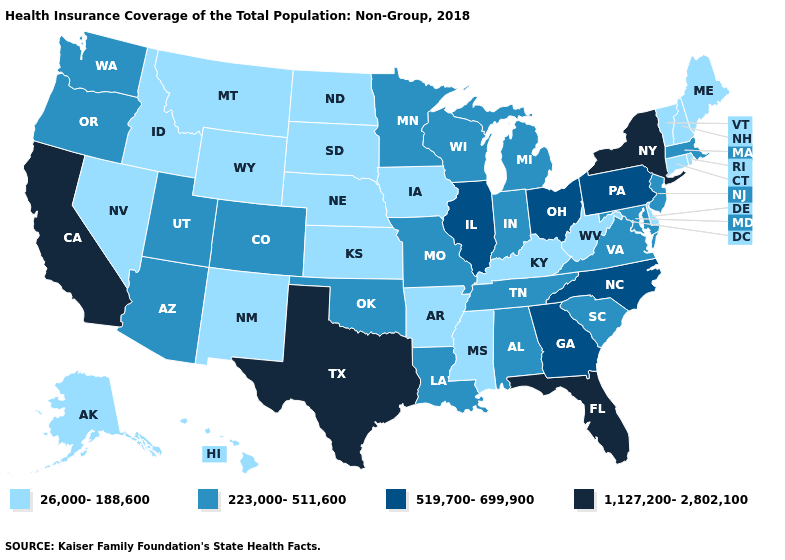Name the states that have a value in the range 1,127,200-2,802,100?
Concise answer only. California, Florida, New York, Texas. Name the states that have a value in the range 26,000-188,600?
Keep it brief. Alaska, Arkansas, Connecticut, Delaware, Hawaii, Idaho, Iowa, Kansas, Kentucky, Maine, Mississippi, Montana, Nebraska, Nevada, New Hampshire, New Mexico, North Dakota, Rhode Island, South Dakota, Vermont, West Virginia, Wyoming. Name the states that have a value in the range 26,000-188,600?
Concise answer only. Alaska, Arkansas, Connecticut, Delaware, Hawaii, Idaho, Iowa, Kansas, Kentucky, Maine, Mississippi, Montana, Nebraska, Nevada, New Hampshire, New Mexico, North Dakota, Rhode Island, South Dakota, Vermont, West Virginia, Wyoming. What is the value of Connecticut?
Answer briefly. 26,000-188,600. Among the states that border Pennsylvania , does New Jersey have the lowest value?
Concise answer only. No. Does Oregon have the lowest value in the West?
Quick response, please. No. Does California have the same value as Ohio?
Answer briefly. No. How many symbols are there in the legend?
Keep it brief. 4. Name the states that have a value in the range 223,000-511,600?
Keep it brief. Alabama, Arizona, Colorado, Indiana, Louisiana, Maryland, Massachusetts, Michigan, Minnesota, Missouri, New Jersey, Oklahoma, Oregon, South Carolina, Tennessee, Utah, Virginia, Washington, Wisconsin. Name the states that have a value in the range 1,127,200-2,802,100?
Quick response, please. California, Florida, New York, Texas. Which states have the highest value in the USA?
Keep it brief. California, Florida, New York, Texas. Name the states that have a value in the range 1,127,200-2,802,100?
Give a very brief answer. California, Florida, New York, Texas. What is the value of North Carolina?
Concise answer only. 519,700-699,900. What is the lowest value in the Northeast?
Be succinct. 26,000-188,600. 